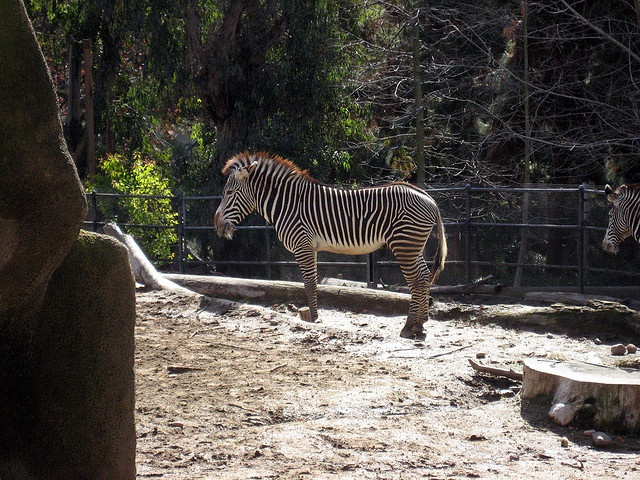Describe the objects in this image and their specific colors. I can see zebra in black, gray, and darkgray tones and zebra in black and gray tones in this image. 